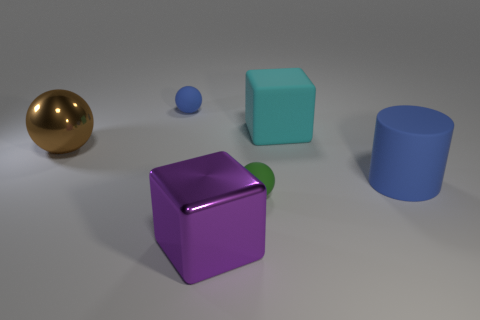Subtract all tiny blue rubber spheres. How many spheres are left? 2 Subtract 1 balls. How many balls are left? 2 Add 1 blue matte things. How many objects exist? 7 Subtract all cylinders. How many objects are left? 5 Subtract all purple balls. Subtract all brown cylinders. How many balls are left? 3 Subtract 0 yellow cylinders. How many objects are left? 6 Subtract all purple blocks. Subtract all blue rubber balls. How many objects are left? 4 Add 2 big rubber objects. How many big rubber objects are left? 4 Add 6 purple things. How many purple things exist? 7 